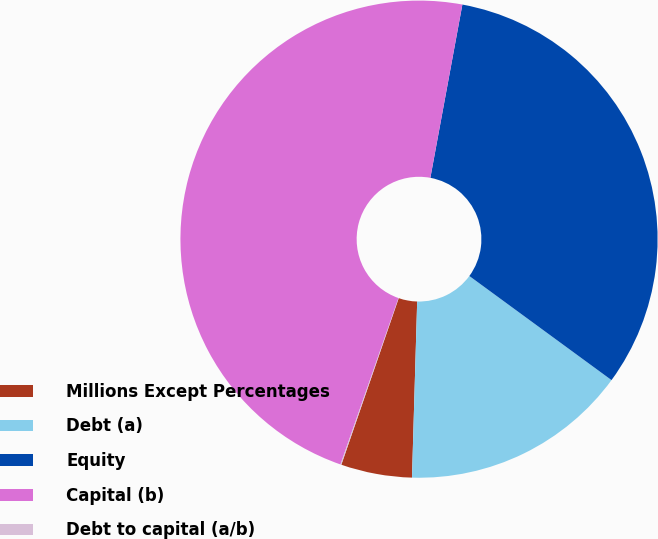Convert chart. <chart><loc_0><loc_0><loc_500><loc_500><pie_chart><fcel>Millions Except Percentages<fcel>Debt (a)<fcel>Equity<fcel>Capital (b)<fcel>Debt to capital (a/b)<nl><fcel>4.81%<fcel>15.41%<fcel>32.15%<fcel>47.57%<fcel>0.06%<nl></chart> 